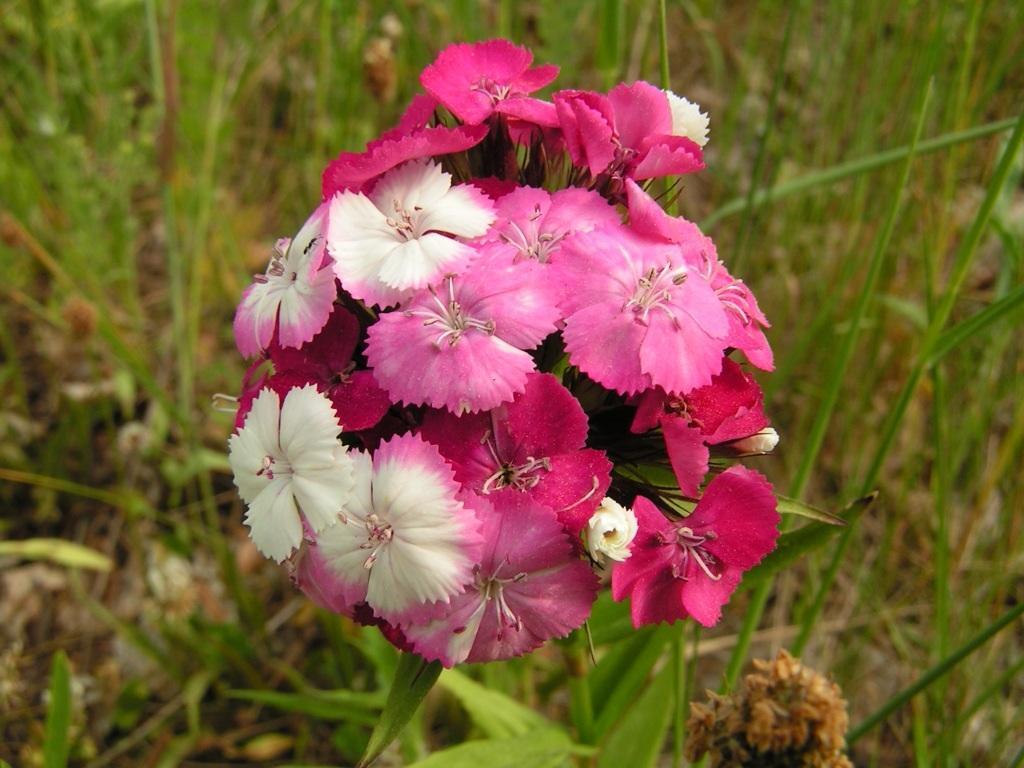Can you describe this image briefly? In this image, I can see a bunch of leaves. In the background, I can see the leaves. 